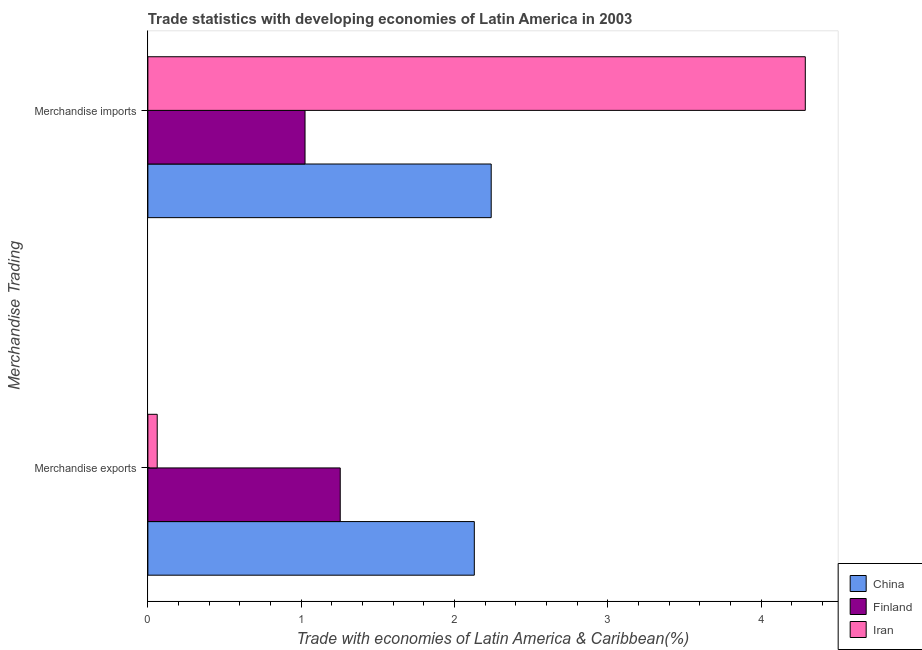How many different coloured bars are there?
Make the answer very short. 3. How many groups of bars are there?
Offer a terse response. 2. Are the number of bars on each tick of the Y-axis equal?
Your answer should be compact. Yes. How many bars are there on the 1st tick from the bottom?
Give a very brief answer. 3. What is the merchandise imports in Iran?
Your answer should be very brief. 4.29. Across all countries, what is the maximum merchandise imports?
Offer a very short reply. 4.29. Across all countries, what is the minimum merchandise exports?
Provide a short and direct response. 0.06. In which country was the merchandise imports minimum?
Provide a succinct answer. Finland. What is the total merchandise imports in the graph?
Make the answer very short. 7.55. What is the difference between the merchandise exports in Finland and that in China?
Provide a short and direct response. -0.87. What is the difference between the merchandise exports in China and the merchandise imports in Iran?
Ensure brevity in your answer.  -2.16. What is the average merchandise imports per country?
Ensure brevity in your answer.  2.52. What is the difference between the merchandise exports and merchandise imports in China?
Your answer should be very brief. -0.11. What is the ratio of the merchandise imports in Finland to that in Iran?
Keep it short and to the point. 0.24. Is the merchandise imports in China less than that in Iran?
Offer a very short reply. Yes. What does the 1st bar from the top in Merchandise exports represents?
Your answer should be very brief. Iran. What does the 3rd bar from the bottom in Merchandise imports represents?
Your answer should be very brief. Iran. How many bars are there?
Offer a terse response. 6. How many countries are there in the graph?
Offer a very short reply. 3. What is the difference between two consecutive major ticks on the X-axis?
Your answer should be compact. 1. Are the values on the major ticks of X-axis written in scientific E-notation?
Provide a succinct answer. No. Does the graph contain any zero values?
Your answer should be compact. No. Where does the legend appear in the graph?
Your answer should be very brief. Bottom right. How many legend labels are there?
Provide a short and direct response. 3. How are the legend labels stacked?
Provide a short and direct response. Vertical. What is the title of the graph?
Offer a very short reply. Trade statistics with developing economies of Latin America in 2003. What is the label or title of the X-axis?
Offer a very short reply. Trade with economies of Latin America & Caribbean(%). What is the label or title of the Y-axis?
Your response must be concise. Merchandise Trading. What is the Trade with economies of Latin America & Caribbean(%) in China in Merchandise exports?
Your answer should be very brief. 2.13. What is the Trade with economies of Latin America & Caribbean(%) in Finland in Merchandise exports?
Make the answer very short. 1.25. What is the Trade with economies of Latin America & Caribbean(%) in Iran in Merchandise exports?
Ensure brevity in your answer.  0.06. What is the Trade with economies of Latin America & Caribbean(%) of China in Merchandise imports?
Keep it short and to the point. 2.24. What is the Trade with economies of Latin America & Caribbean(%) of Finland in Merchandise imports?
Provide a short and direct response. 1.03. What is the Trade with economies of Latin America & Caribbean(%) of Iran in Merchandise imports?
Ensure brevity in your answer.  4.29. Across all Merchandise Trading, what is the maximum Trade with economies of Latin America & Caribbean(%) in China?
Provide a succinct answer. 2.24. Across all Merchandise Trading, what is the maximum Trade with economies of Latin America & Caribbean(%) of Finland?
Offer a very short reply. 1.25. Across all Merchandise Trading, what is the maximum Trade with economies of Latin America & Caribbean(%) in Iran?
Your response must be concise. 4.29. Across all Merchandise Trading, what is the minimum Trade with economies of Latin America & Caribbean(%) in China?
Offer a terse response. 2.13. Across all Merchandise Trading, what is the minimum Trade with economies of Latin America & Caribbean(%) in Finland?
Offer a terse response. 1.03. Across all Merchandise Trading, what is the minimum Trade with economies of Latin America & Caribbean(%) in Iran?
Make the answer very short. 0.06. What is the total Trade with economies of Latin America & Caribbean(%) in China in the graph?
Offer a very short reply. 4.37. What is the total Trade with economies of Latin America & Caribbean(%) of Finland in the graph?
Keep it short and to the point. 2.28. What is the total Trade with economies of Latin America & Caribbean(%) of Iran in the graph?
Offer a very short reply. 4.35. What is the difference between the Trade with economies of Latin America & Caribbean(%) in China in Merchandise exports and that in Merchandise imports?
Your response must be concise. -0.11. What is the difference between the Trade with economies of Latin America & Caribbean(%) of Finland in Merchandise exports and that in Merchandise imports?
Keep it short and to the point. 0.23. What is the difference between the Trade with economies of Latin America & Caribbean(%) of Iran in Merchandise exports and that in Merchandise imports?
Offer a terse response. -4.23. What is the difference between the Trade with economies of Latin America & Caribbean(%) of China in Merchandise exports and the Trade with economies of Latin America & Caribbean(%) of Finland in Merchandise imports?
Offer a very short reply. 1.1. What is the difference between the Trade with economies of Latin America & Caribbean(%) in China in Merchandise exports and the Trade with economies of Latin America & Caribbean(%) in Iran in Merchandise imports?
Give a very brief answer. -2.16. What is the difference between the Trade with economies of Latin America & Caribbean(%) in Finland in Merchandise exports and the Trade with economies of Latin America & Caribbean(%) in Iran in Merchandise imports?
Give a very brief answer. -3.03. What is the average Trade with economies of Latin America & Caribbean(%) in China per Merchandise Trading?
Offer a very short reply. 2.18. What is the average Trade with economies of Latin America & Caribbean(%) of Finland per Merchandise Trading?
Provide a short and direct response. 1.14. What is the average Trade with economies of Latin America & Caribbean(%) in Iran per Merchandise Trading?
Keep it short and to the point. 2.17. What is the difference between the Trade with economies of Latin America & Caribbean(%) in China and Trade with economies of Latin America & Caribbean(%) in Finland in Merchandise exports?
Offer a terse response. 0.87. What is the difference between the Trade with economies of Latin America & Caribbean(%) in China and Trade with economies of Latin America & Caribbean(%) in Iran in Merchandise exports?
Offer a very short reply. 2.07. What is the difference between the Trade with economies of Latin America & Caribbean(%) of Finland and Trade with economies of Latin America & Caribbean(%) of Iran in Merchandise exports?
Your answer should be very brief. 1.19. What is the difference between the Trade with economies of Latin America & Caribbean(%) in China and Trade with economies of Latin America & Caribbean(%) in Finland in Merchandise imports?
Your answer should be compact. 1.21. What is the difference between the Trade with economies of Latin America & Caribbean(%) of China and Trade with economies of Latin America & Caribbean(%) of Iran in Merchandise imports?
Your answer should be compact. -2.05. What is the difference between the Trade with economies of Latin America & Caribbean(%) in Finland and Trade with economies of Latin America & Caribbean(%) in Iran in Merchandise imports?
Your answer should be very brief. -3.26. What is the ratio of the Trade with economies of Latin America & Caribbean(%) of China in Merchandise exports to that in Merchandise imports?
Give a very brief answer. 0.95. What is the ratio of the Trade with economies of Latin America & Caribbean(%) of Finland in Merchandise exports to that in Merchandise imports?
Offer a very short reply. 1.22. What is the ratio of the Trade with economies of Latin America & Caribbean(%) in Iran in Merchandise exports to that in Merchandise imports?
Your response must be concise. 0.01. What is the difference between the highest and the second highest Trade with economies of Latin America & Caribbean(%) in China?
Provide a short and direct response. 0.11. What is the difference between the highest and the second highest Trade with economies of Latin America & Caribbean(%) in Finland?
Keep it short and to the point. 0.23. What is the difference between the highest and the second highest Trade with economies of Latin America & Caribbean(%) in Iran?
Your answer should be very brief. 4.23. What is the difference between the highest and the lowest Trade with economies of Latin America & Caribbean(%) of China?
Ensure brevity in your answer.  0.11. What is the difference between the highest and the lowest Trade with economies of Latin America & Caribbean(%) of Finland?
Keep it short and to the point. 0.23. What is the difference between the highest and the lowest Trade with economies of Latin America & Caribbean(%) of Iran?
Keep it short and to the point. 4.23. 